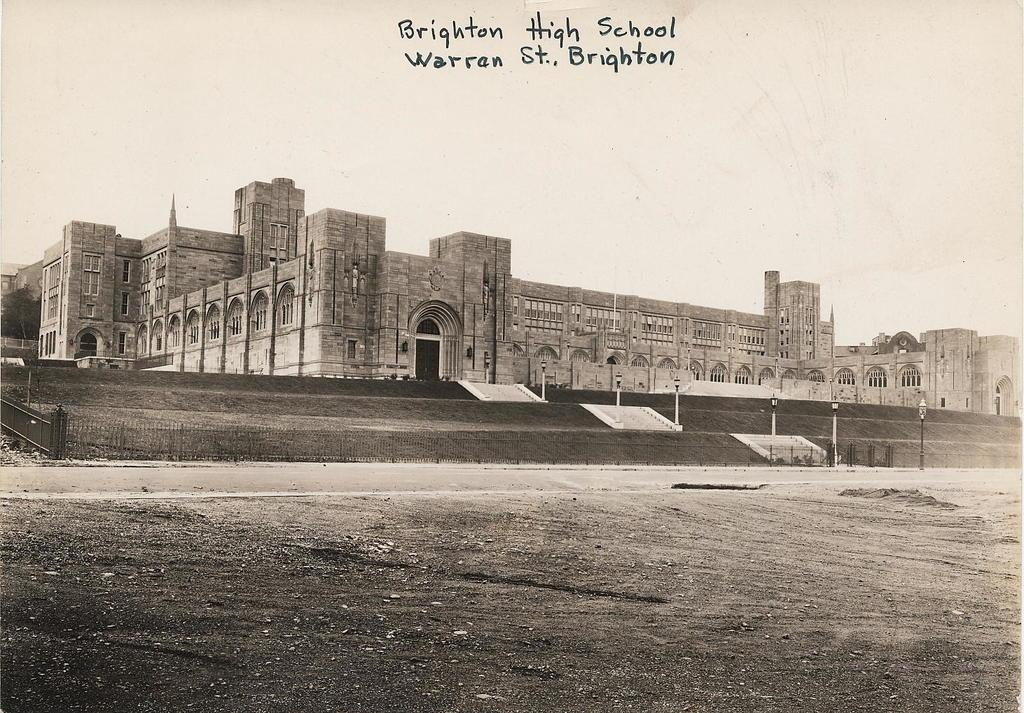<image>
Summarize the visual content of the image. A black and white photo of Brighton High School. 